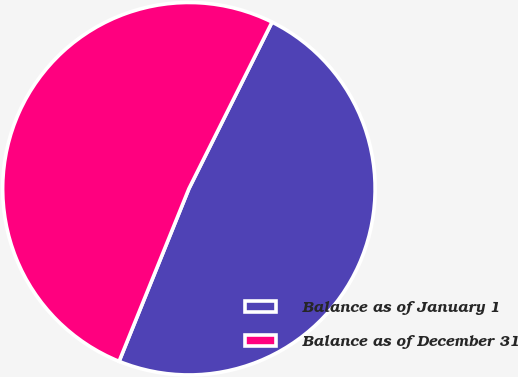<chart> <loc_0><loc_0><loc_500><loc_500><pie_chart><fcel>Balance as of January 1<fcel>Balance as of December 31<nl><fcel>48.75%<fcel>51.25%<nl></chart> 